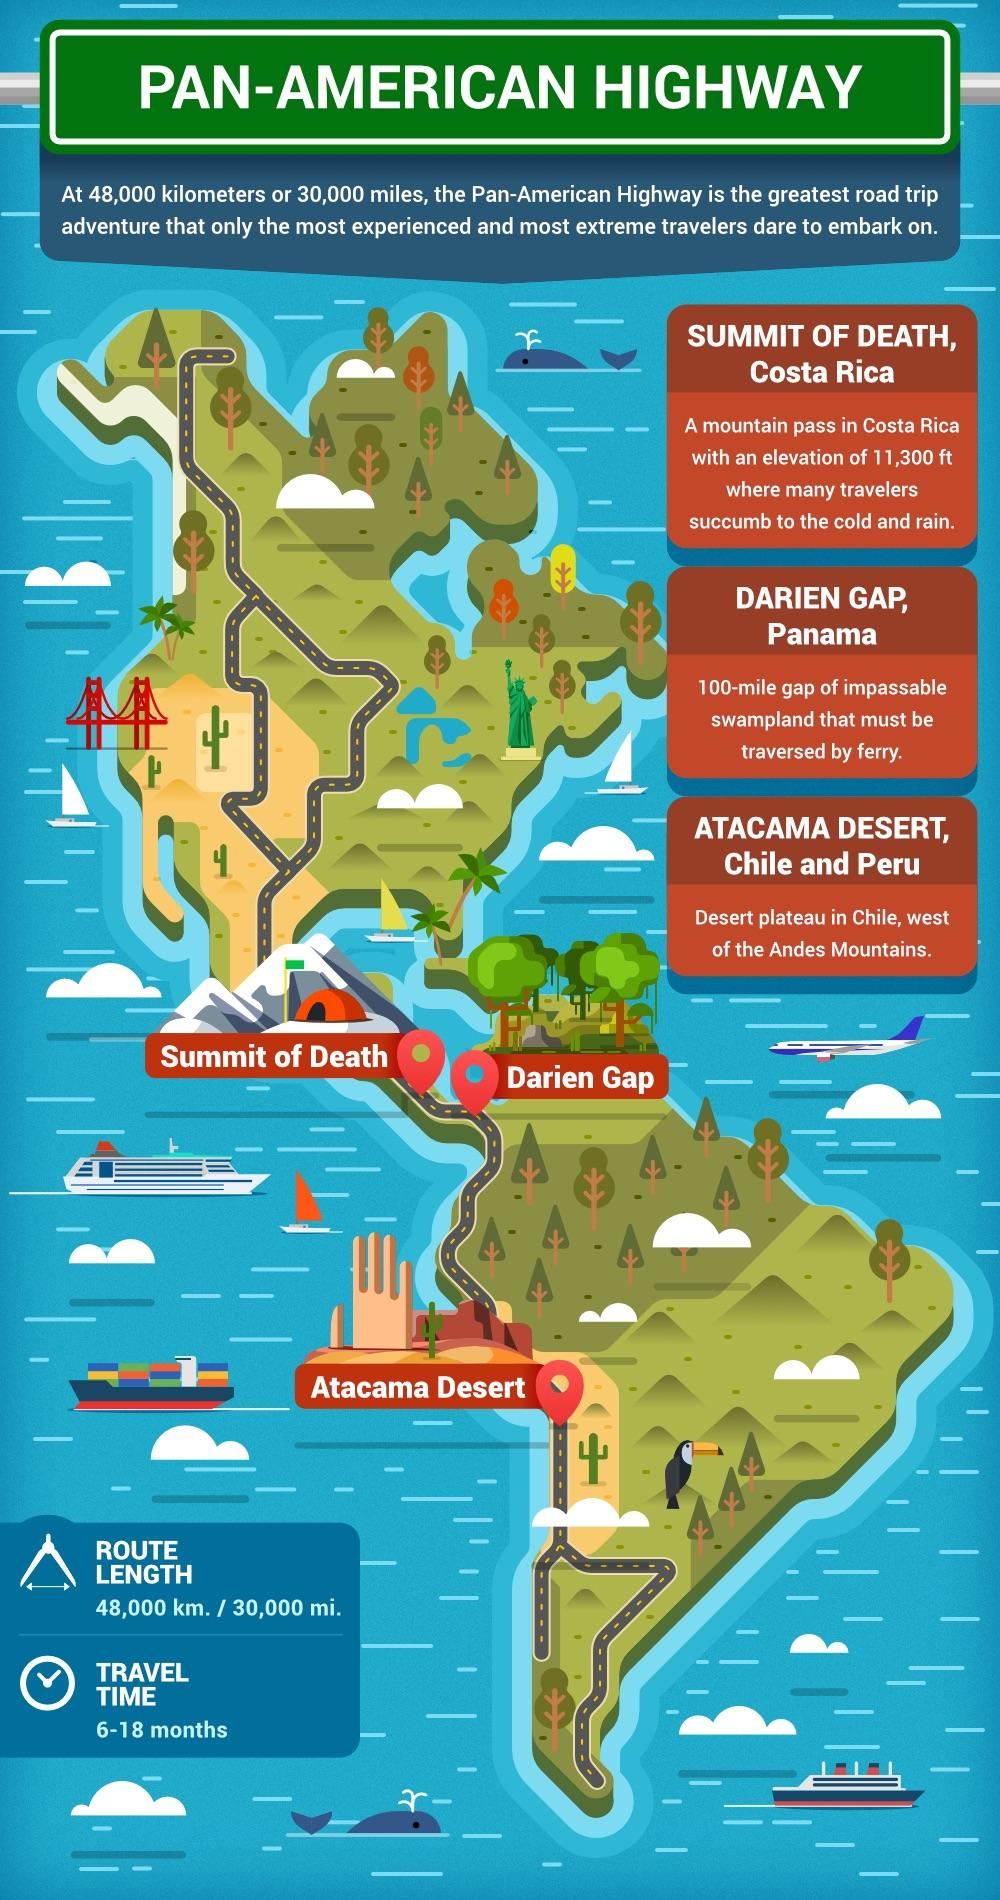Outline some significant characteristics in this image. The locations of Summit of Death, Darien Gap, and Atacama Desert have been identified as the most dangerous roads in the world. 